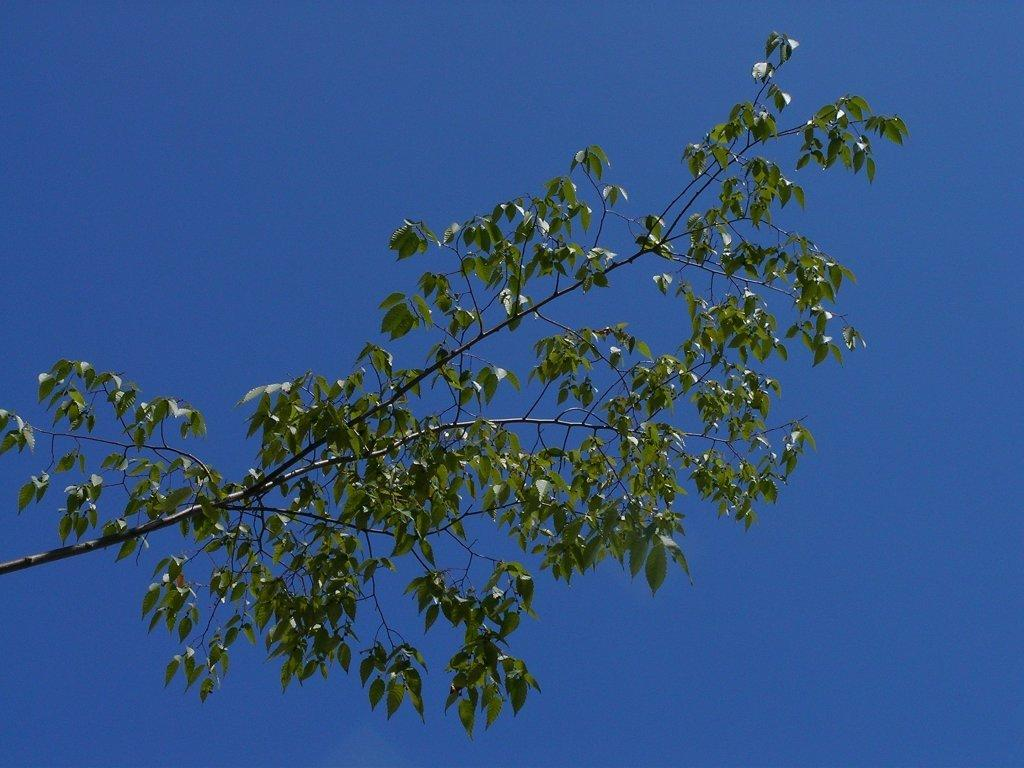What type of plant can be seen in the image? There is a tree with leaves in the image. What part of the natural environment is visible in the background of the image? The sky is visible in the background of the image. How many eyes can be seen on the tree in the image? There are no eyes present on the tree in the image, as trees do not have eyes. 